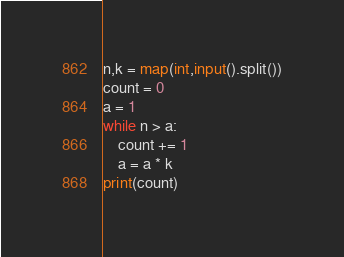Convert code to text. <code><loc_0><loc_0><loc_500><loc_500><_Python_>n,k = map(int,input().split())
count = 0
a = 1
while n > a:
    count += 1
    a = a * k
print(count)</code> 